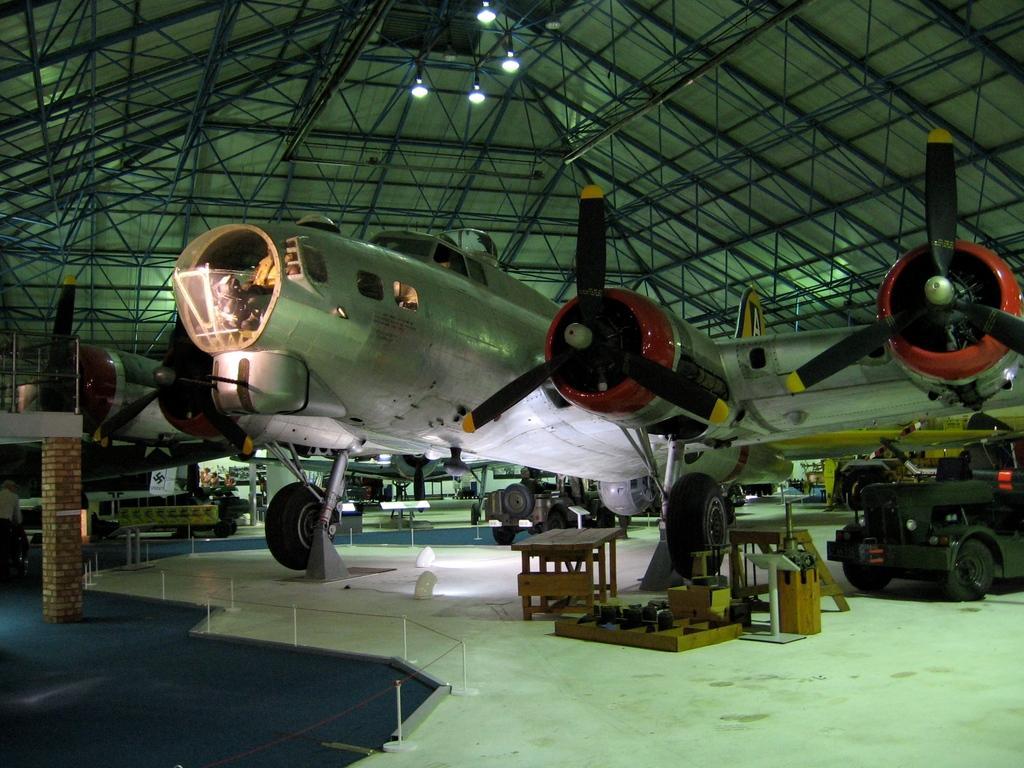Can you describe this image briefly? in this image I can see an aircraft and a vehicle. 